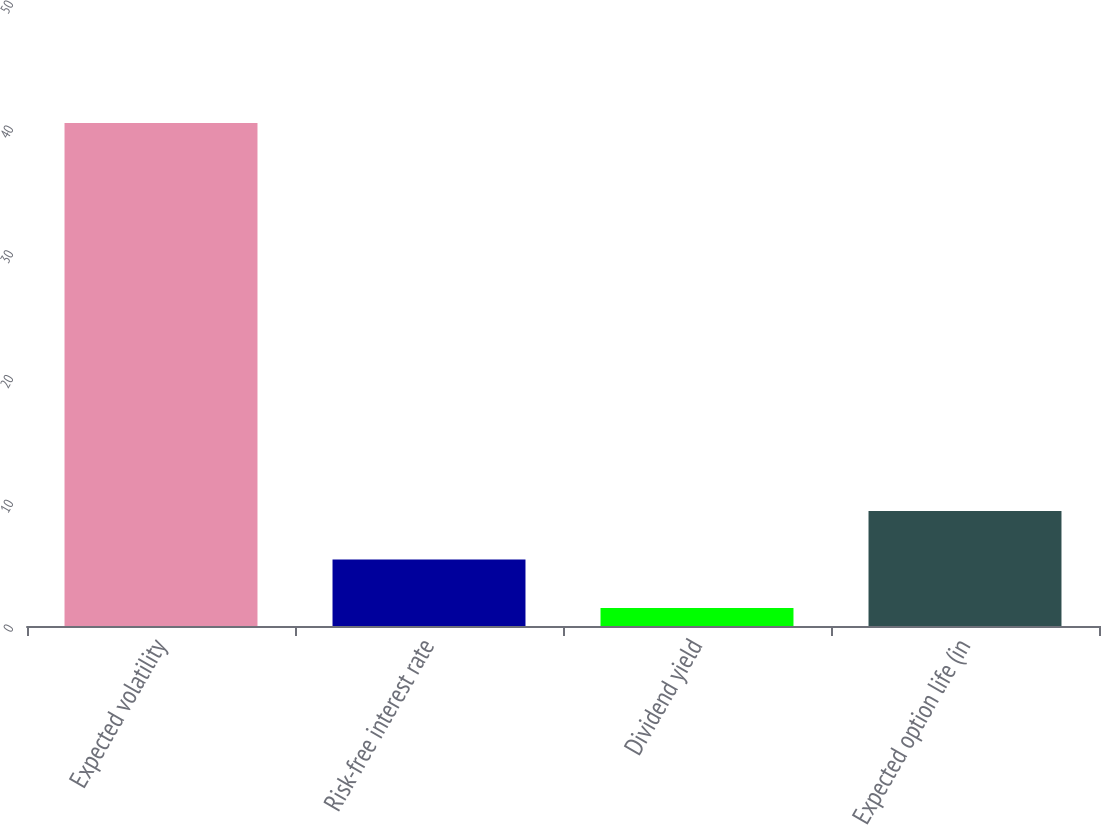<chart> <loc_0><loc_0><loc_500><loc_500><bar_chart><fcel>Expected volatility<fcel>Risk-free interest rate<fcel>Dividend yield<fcel>Expected option life (in<nl><fcel>40.31<fcel>5.33<fcel>1.44<fcel>9.22<nl></chart> 